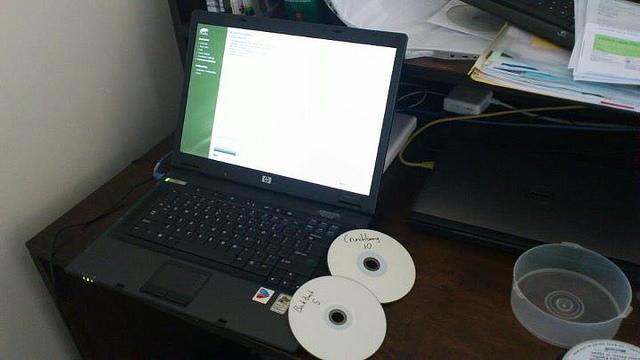Where is the mouse?
Concise answer only. On laptop. What sits atop the computer?
Short answer required. Cds. Are these both Apple laptops?
Give a very brief answer. No. Is this person running a program?
Concise answer only. Yes. Is the computer using an Apple operating system?
Short answer required. No. Is there handwriting on the two CD's to the left of the computer?
Write a very short answer. Yes. What is the brand of this computer?
Be succinct. Hp. What color is the left side of the screen?
Give a very brief answer. Green. 